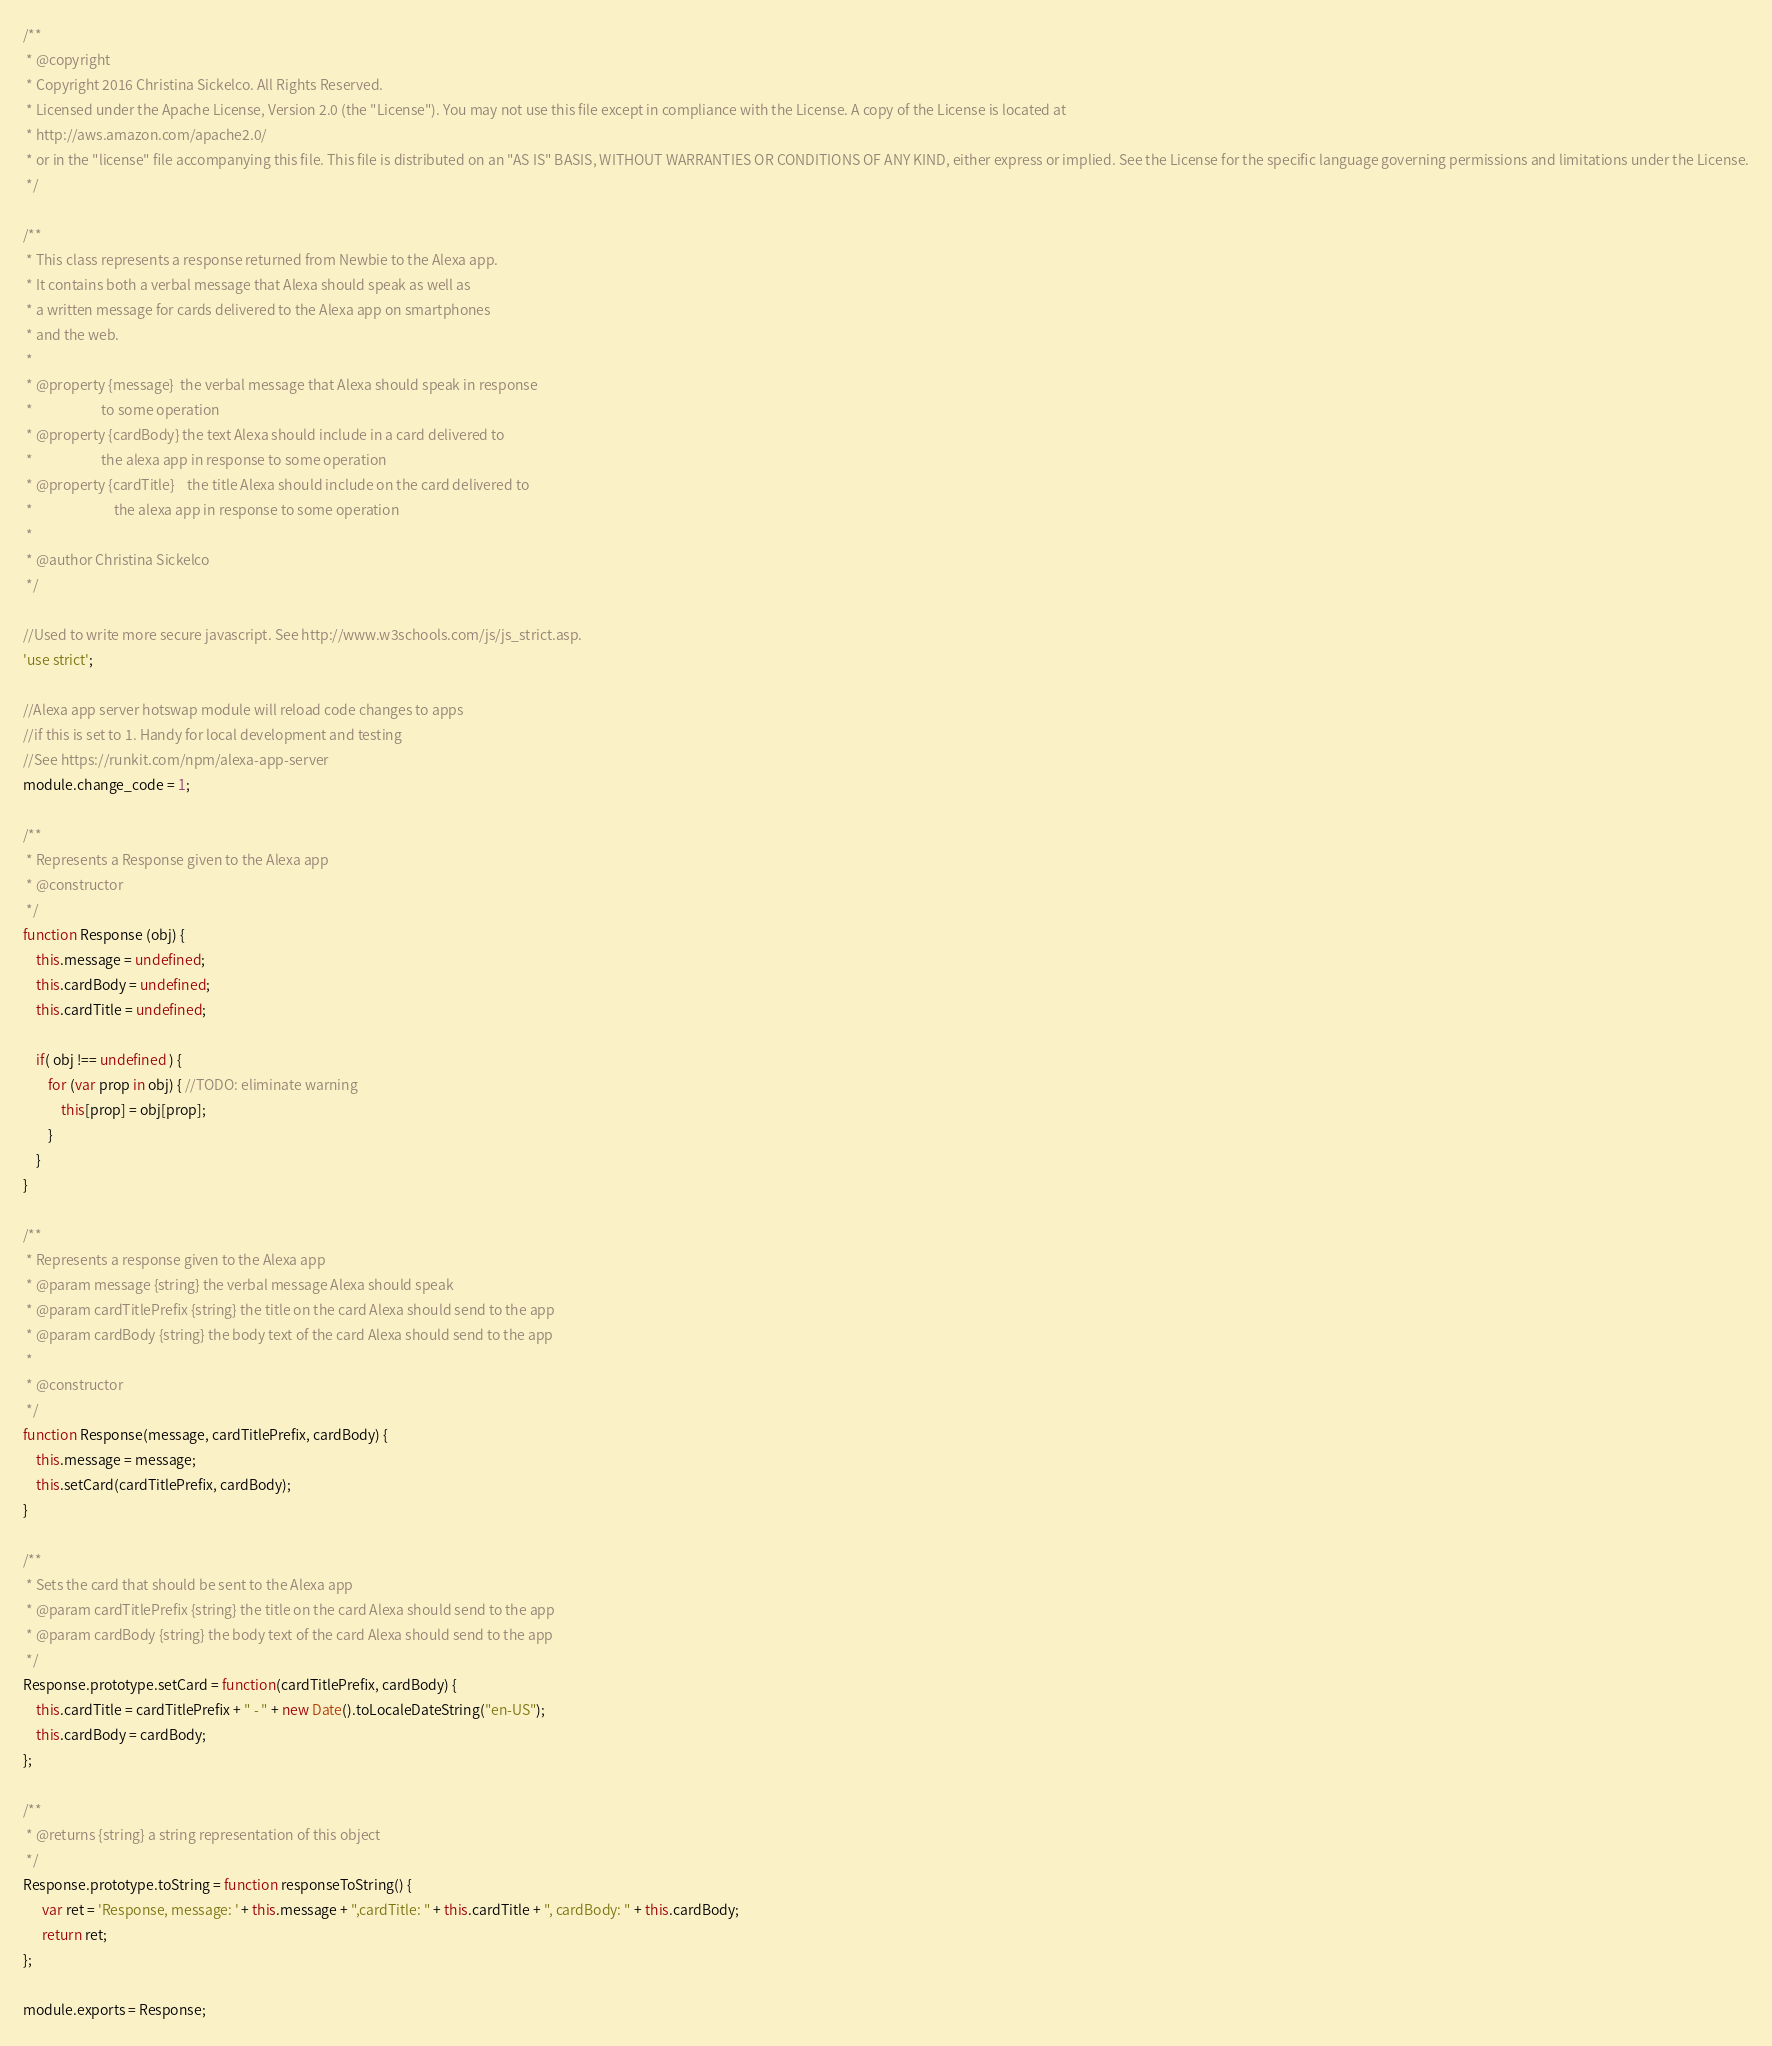Convert code to text. <code><loc_0><loc_0><loc_500><loc_500><_JavaScript_>/**
 * @copyright
 * Copyright 2016 Christina Sickelco. All Rights Reserved.
 * Licensed under the Apache License, Version 2.0 (the "License"). You may not use this file except in compliance with the License. A copy of the License is located at
 * http://aws.amazon.com/apache2.0/
 * or in the "license" file accompanying this file. This file is distributed on an "AS IS" BASIS, WITHOUT WARRANTIES OR CONDITIONS OF ANY KIND, either express or implied. See the License for the specific language governing permissions and limitations under the License.
 */

/**
 * This class represents a response returned from Newbie to the Alexa app.
 * It contains both a verbal message that Alexa should speak as well as
 * a written message for cards delivered to the Alexa app on smartphones
 * and the web.
 * 
 * @property {message} 	the verbal message that Alexa should speak in response
 * 						to some operation
 * @property {cardBody}	the text Alexa should include in a card delivered to
 * 						the alexa app in response to some operation
 * @property {cardTitle}	the title Alexa should include on the card delivered to
 * 							the alexa app in response to some operation
 * 
 * @author Christina Sickelco
 */

//Used to write more secure javascript. See http://www.w3schools.com/js/js_strict.asp.
'use strict';

//Alexa app server hotswap module will reload code changes to apps
//if this is set to 1. Handy for local development and testing
//See https://runkit.com/npm/alexa-app-server
module.change_code = 1;

/**
 * Represents a Response given to the Alexa app
 * @constructor
 */
function Response (obj) {
	this.message = undefined;
	this.cardBody = undefined;
	this.cardTitle = undefined;
	
	if( obj !== undefined ) {
		for (var prop in obj) { //TODO: eliminate warning
			this[prop] = obj[prop];
		}
	}
}

/**
 * Represents a response given to the Alexa app
 * @param message {string} the verbal message Alexa should speak
 * @param cardTitlePrefix {string} the title on the card Alexa should send to the app
 * @param cardBody {string} the body text of the card Alexa should send to the app
 * 
 * @constructor
 */
function Response(message, cardTitlePrefix, cardBody) {
	this.message = message;
	this.setCard(cardTitlePrefix, cardBody);
}

/**
 * Sets the card that should be sent to the Alexa app
 * @param cardTitlePrefix {string} the title on the card Alexa should send to the app
 * @param cardBody {string} the body text of the card Alexa should send to the app
 */
Response.prototype.setCard = function(cardTitlePrefix, cardBody) {
	this.cardTitle = cardTitlePrefix + " - " + new Date().toLocaleDateString("en-US");
	this.cardBody = cardBody;
};

/**
 * @returns {string} a string representation of this object
 */
Response.prototype.toString = function responseToString() {
	  var ret = 'Response, message: ' + this.message + ",cardTitle: " + this.cardTitle + ", cardBody: " + this.cardBody;
	  return ret;
};

module.exports = Response;</code> 